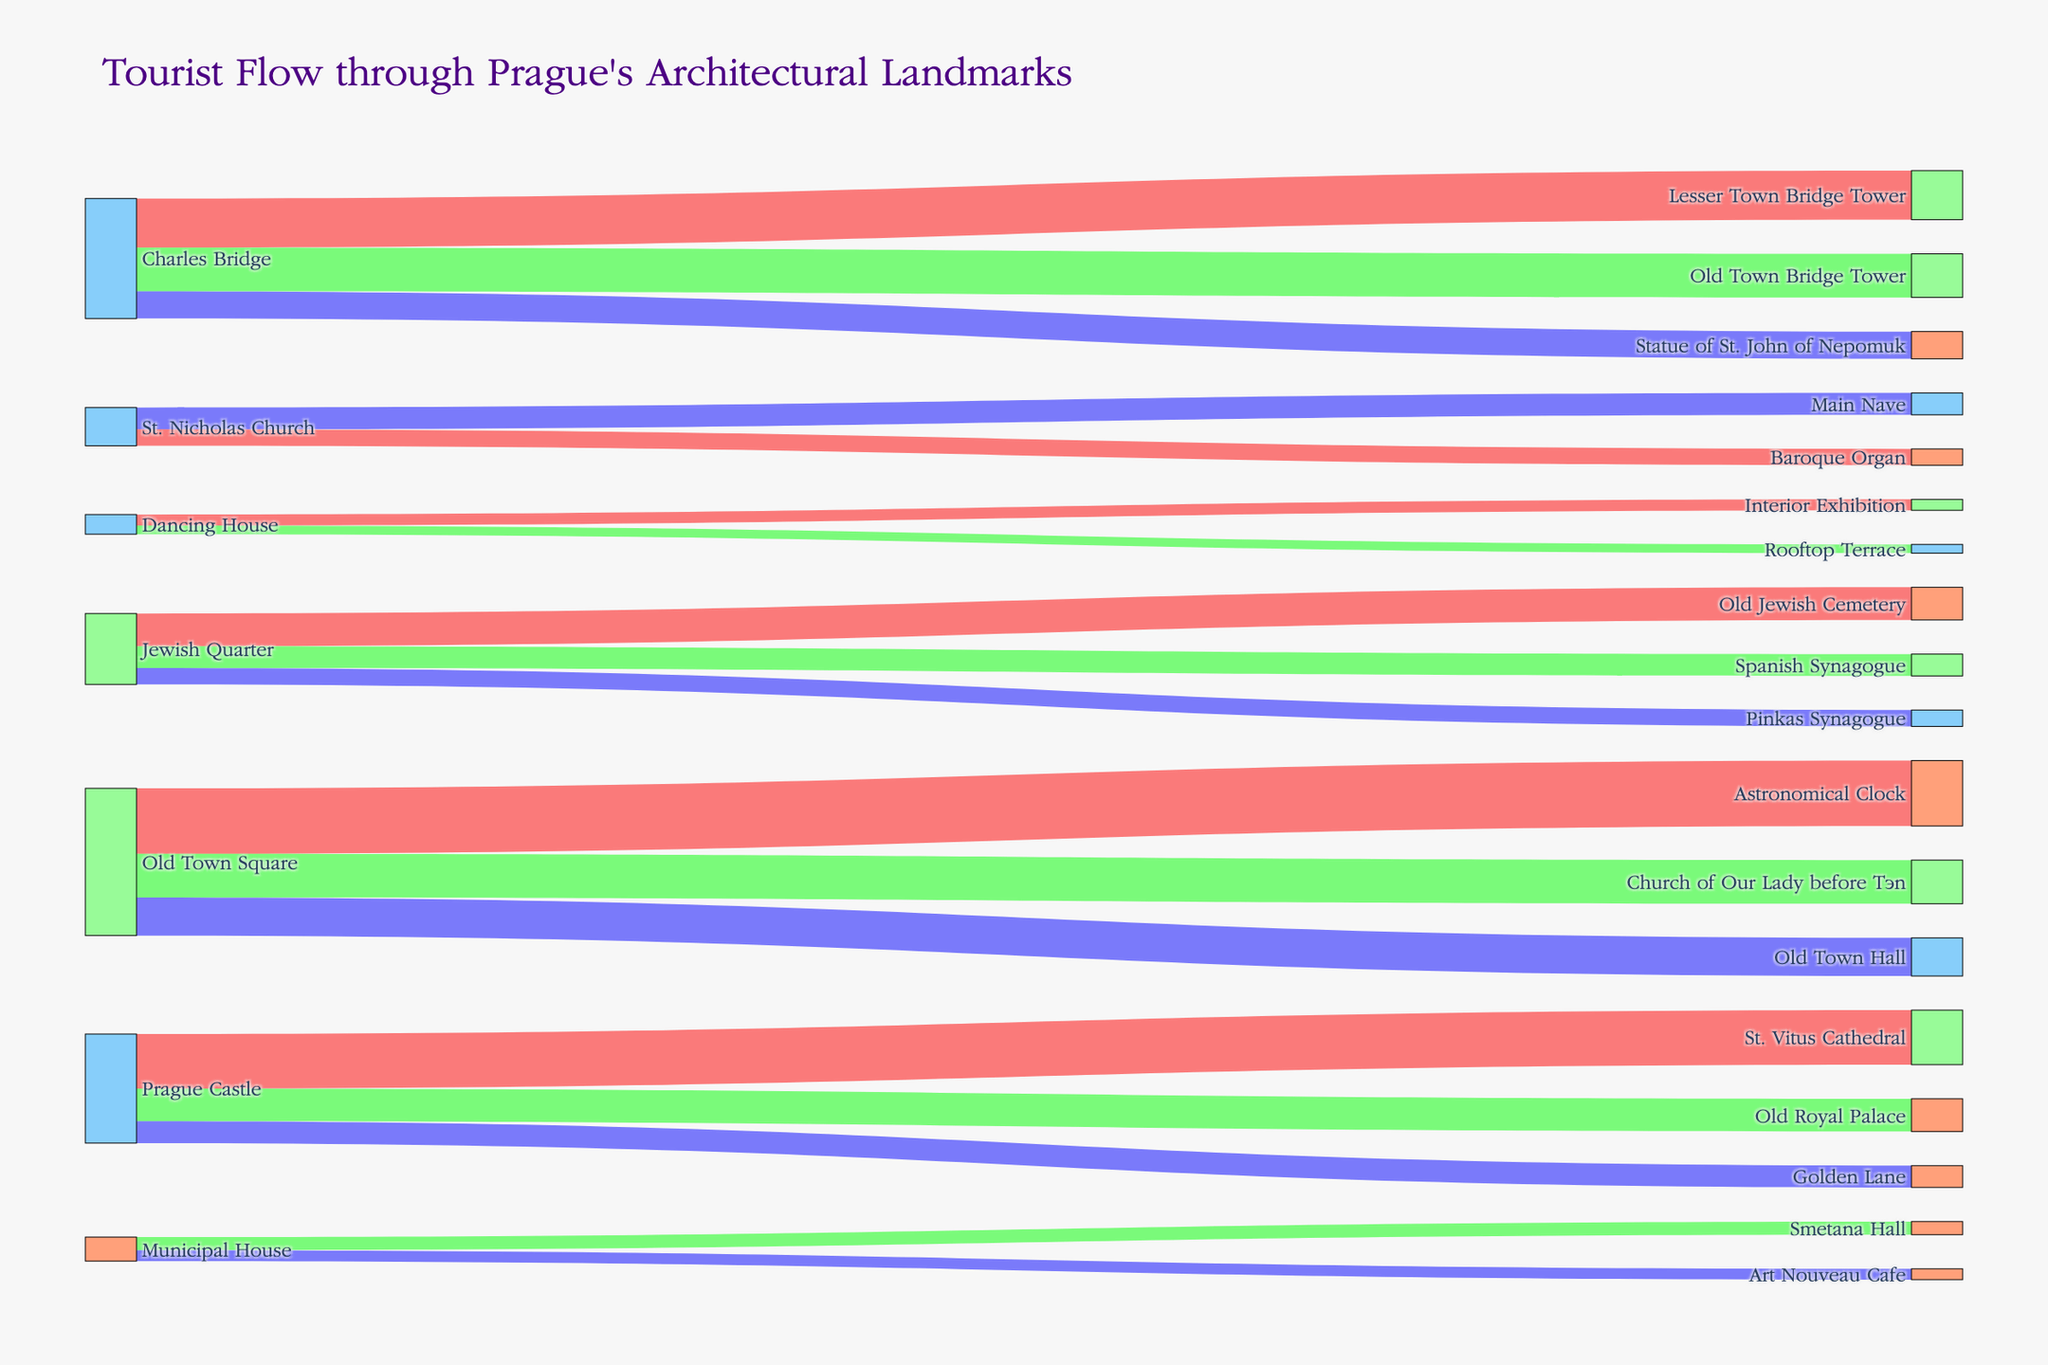What's the title of the Sankey diagram? The title is typically displayed at the top of the chart. In the given data, it's specified as "Tourist Flow through Prague's Architectural Landmarks".
Answer: "Tourist Flow through Prague's Architectural Landmarks" Which landmark has the highest tourist flow originating from Prague Castle? To answer, you need to compare the flows from Prague Castle to its connected landmarks: St. Vitus Cathedral (500,000), Old Royal Palace (300,000), and Golden Lane (200,000). The highest tourist flow is to St. Vitus Cathedral.
Answer: St. Vitus Cathedral How many tourists visit the Church of Our Lady before Týn? Find the flow from Old Town Square to Church of Our Lady before Týn, which is given as 400,000 in the data.
Answer: 400,000 What is the combined tourist flow from Charles Bridge to its connected landmarks? Sum the flows from Charles Bridge to its connected landmarks: Lesser Town Bridge Tower (450,000), Old Town Bridge Tower (400,000), and Statue of St. John of Nepomuk (250,000). The total is 450,000 + 400,000 + 250,000 = 1,100,000
Answer: 1,100,000 Which landmark receives a higher tourist flow, Old Town Hall or Old Jewish Cemetery? Compare the tourist flows: Old Town Hall (350,000) and Old Jewish Cemetery (300,000). Old Town Hall has a higher flow.
Answer: Old Town Hall What's the least visited landmark in the Jewish Quarter? Check the flows to landmarks in the Jewish Quarter: Old Jewish Cemetery (300,000), Spanish Synagogue (200,000), and Pinkas Synagogue (150,000). Pinkas Synagogue has the least visitors.
Answer: Pinkas Synagogue Is the total tourist flow to the Dancing House greater or less than the flow to the Municipal House? Check the flows to Dancing House: Interior Exhibition (100,000) + Rooftop Terrace (80,000) = 180,000. For the Municipal House: Smetana Hall (120,000) + Art Nouveau Cafe (100,000) = 220,000. Compare 180,000 (Dancing House) with 220,000 (Municipal House).
Answer: Less How many tourists visit the Prague Castle attractions in total? Sum the tourists visiting each attraction from Prague Castle: St. Vitus Cathedral (500,000) + Old Royal Palace (300,000) + Golden Lane (200,000) = 1,000,000
Answer: 1,000,000 Which landmark connected to the Old Town Square has the lowest tourist flow? Compare the flows to each landmark: Astronomical Clock (600,000), Church of Our Lady before Týn (400,000), and Old Town Hall (350,000). Old Town Hall has the lowest flow.
Answer: Old Town Hall 